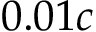Convert formula to latex. <formula><loc_0><loc_0><loc_500><loc_500>0 . 0 1 c</formula> 